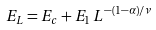<formula> <loc_0><loc_0><loc_500><loc_500>E _ { L } = E _ { c } + E _ { 1 } \, L ^ { - ( 1 - \alpha ) / \nu }</formula> 